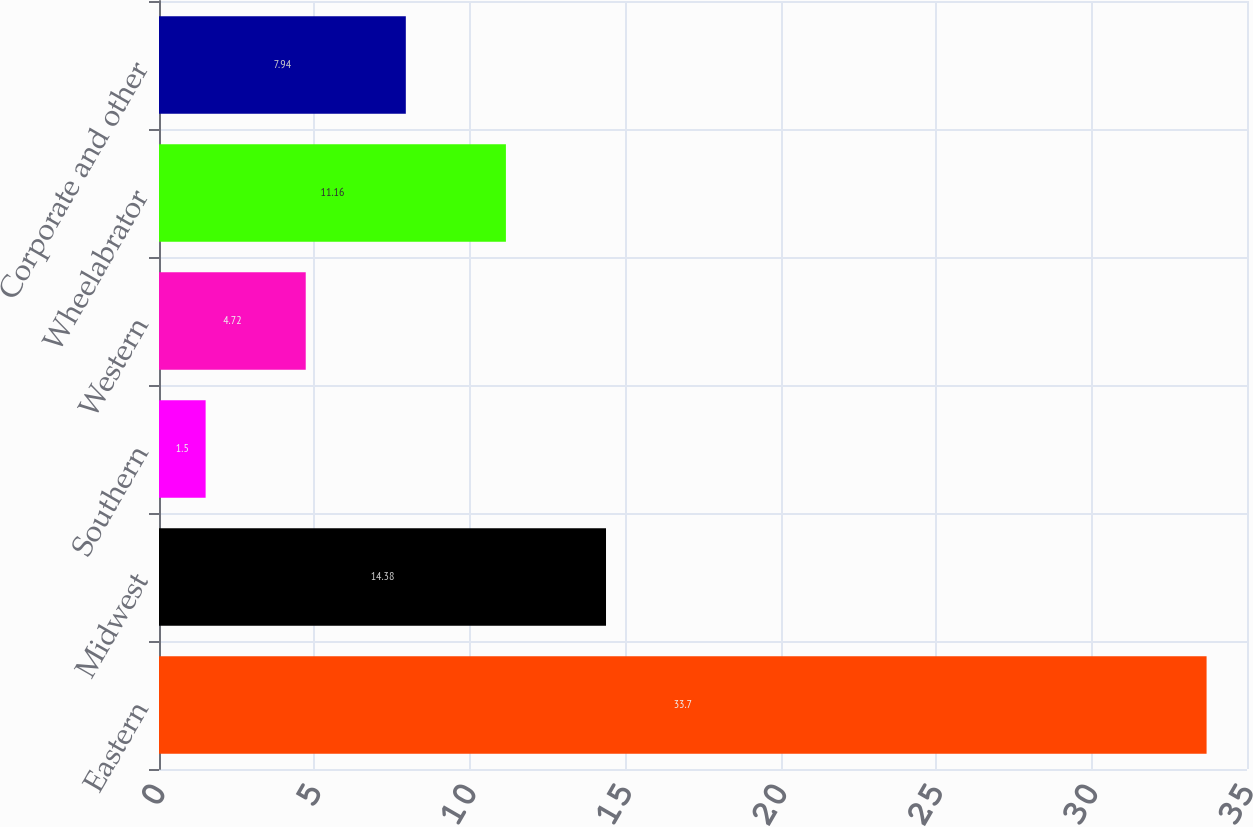Convert chart. <chart><loc_0><loc_0><loc_500><loc_500><bar_chart><fcel>Eastern<fcel>Midwest<fcel>Southern<fcel>Western<fcel>Wheelabrator<fcel>Corporate and other<nl><fcel>33.7<fcel>14.38<fcel>1.5<fcel>4.72<fcel>11.16<fcel>7.94<nl></chart> 